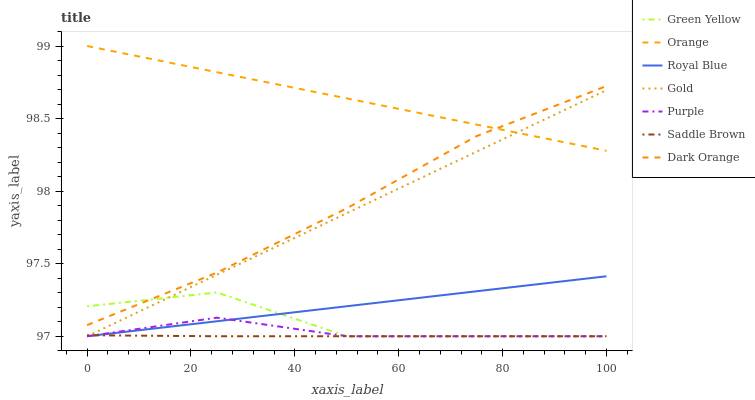Does Saddle Brown have the minimum area under the curve?
Answer yes or no. Yes. Does Orange have the maximum area under the curve?
Answer yes or no. Yes. Does Gold have the minimum area under the curve?
Answer yes or no. No. Does Gold have the maximum area under the curve?
Answer yes or no. No. Is Royal Blue the smoothest?
Answer yes or no. Yes. Is Green Yellow the roughest?
Answer yes or no. Yes. Is Gold the smoothest?
Answer yes or no. No. Is Gold the roughest?
Answer yes or no. No. Does Gold have the lowest value?
Answer yes or no. Yes. Does Orange have the lowest value?
Answer yes or no. No. Does Orange have the highest value?
Answer yes or no. Yes. Does Gold have the highest value?
Answer yes or no. No. Is Royal Blue less than Dark Orange?
Answer yes or no. Yes. Is Orange greater than Saddle Brown?
Answer yes or no. Yes. Does Gold intersect Purple?
Answer yes or no. Yes. Is Gold less than Purple?
Answer yes or no. No. Is Gold greater than Purple?
Answer yes or no. No. Does Royal Blue intersect Dark Orange?
Answer yes or no. No. 